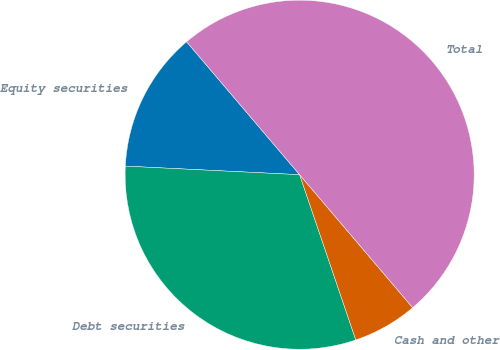Convert chart to OTSL. <chart><loc_0><loc_0><loc_500><loc_500><pie_chart><fcel>Equity securities<fcel>Debt securities<fcel>Cash and other<fcel>Total<nl><fcel>13.0%<fcel>31.0%<fcel>6.0%<fcel>50.0%<nl></chart> 